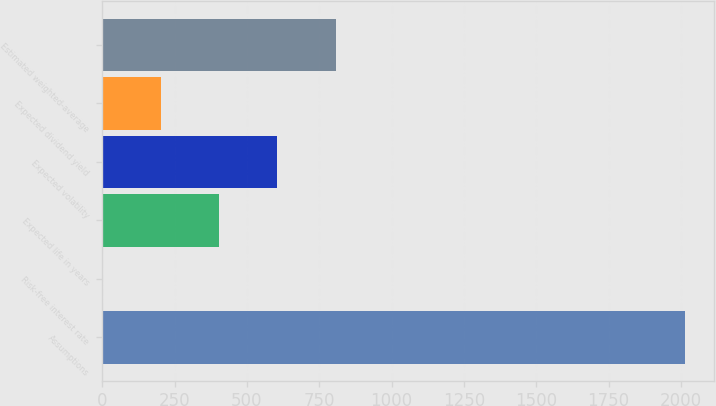<chart> <loc_0><loc_0><loc_500><loc_500><bar_chart><fcel>Assumptions<fcel>Risk-free interest rate<fcel>Expected life in years<fcel>Expected volatility<fcel>Expected dividend yield<fcel>Estimated weighted-average<nl><fcel>2014<fcel>1.23<fcel>403.79<fcel>605.07<fcel>202.51<fcel>806.35<nl></chart> 